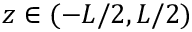Convert formula to latex. <formula><loc_0><loc_0><loc_500><loc_500>z \in ( - L / 2 , L / 2 )</formula> 